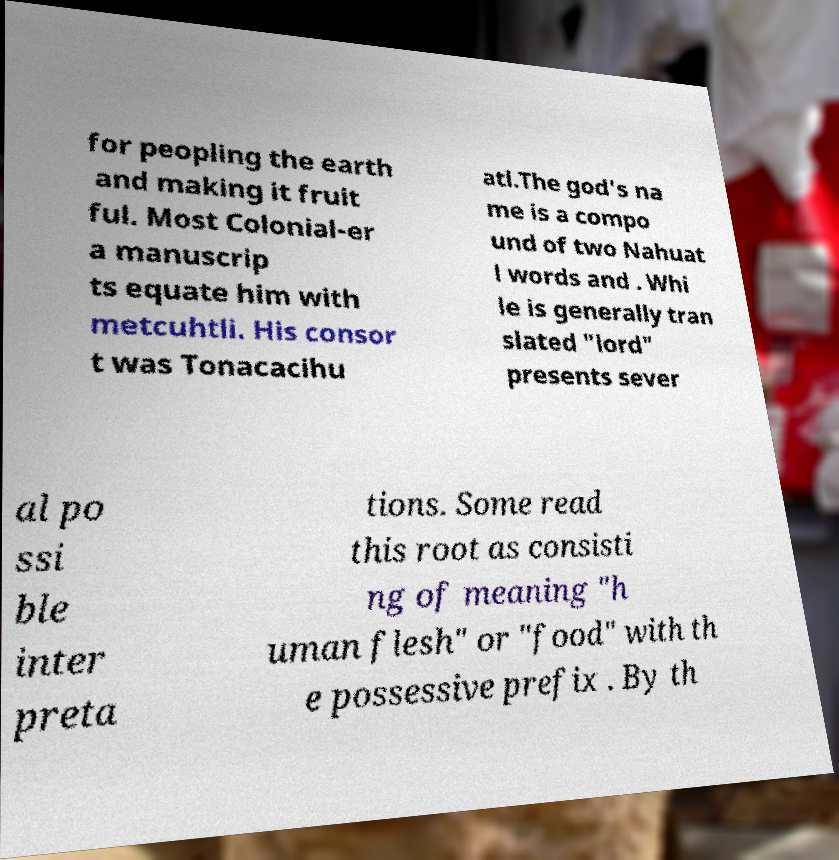For documentation purposes, I need the text within this image transcribed. Could you provide that? for peopling the earth and making it fruit ful. Most Colonial-er a manuscrip ts equate him with metcuhtli. His consor t was Tonacacihu atl.The god's na me is a compo und of two Nahuat l words and . Whi le is generally tran slated "lord" presents sever al po ssi ble inter preta tions. Some read this root as consisti ng of meaning "h uman flesh" or "food" with th e possessive prefix . By th 